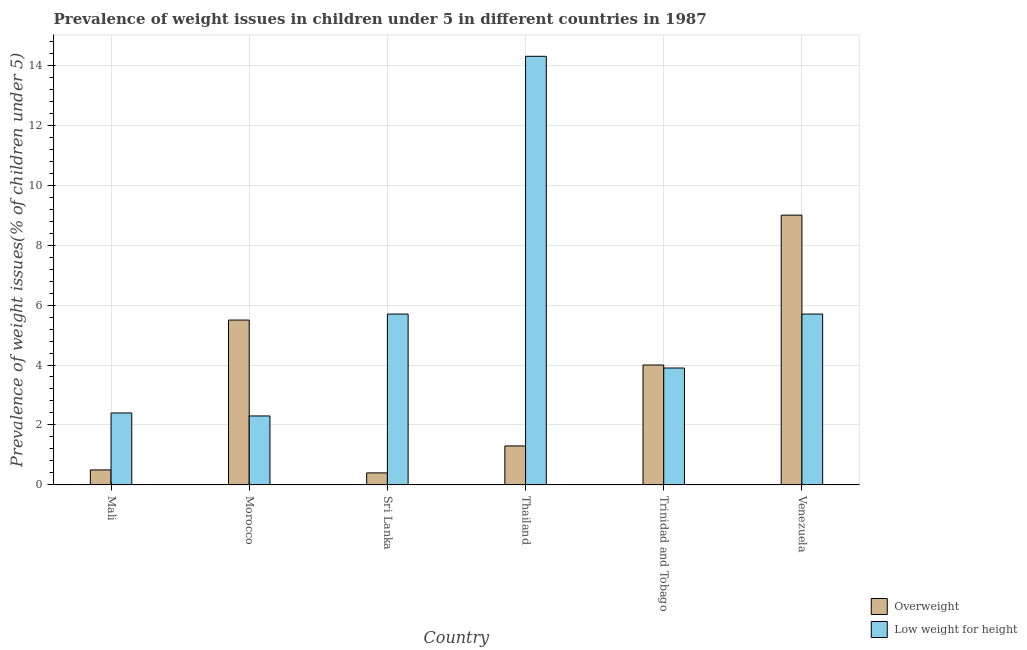How many different coloured bars are there?
Your answer should be very brief. 2. Are the number of bars per tick equal to the number of legend labels?
Offer a terse response. Yes. Are the number of bars on each tick of the X-axis equal?
Make the answer very short. Yes. What is the label of the 4th group of bars from the left?
Make the answer very short. Thailand. What is the percentage of underweight children in Trinidad and Tobago?
Offer a terse response. 3.9. Across all countries, what is the maximum percentage of underweight children?
Your answer should be very brief. 14.3. Across all countries, what is the minimum percentage of underweight children?
Your response must be concise. 2.3. In which country was the percentage of overweight children maximum?
Your response must be concise. Venezuela. In which country was the percentage of underweight children minimum?
Your answer should be very brief. Morocco. What is the total percentage of overweight children in the graph?
Ensure brevity in your answer.  20.7. What is the difference between the percentage of overweight children in Mali and the percentage of underweight children in Venezuela?
Ensure brevity in your answer.  -5.2. What is the average percentage of underweight children per country?
Your answer should be compact. 5.72. What is the difference between the percentage of overweight children and percentage of underweight children in Trinidad and Tobago?
Your answer should be very brief. 0.1. In how many countries, is the percentage of underweight children greater than 12.4 %?
Offer a very short reply. 1. What is the ratio of the percentage of underweight children in Morocco to that in Trinidad and Tobago?
Offer a very short reply. 0.59. Is the difference between the percentage of overweight children in Morocco and Venezuela greater than the difference between the percentage of underweight children in Morocco and Venezuela?
Offer a very short reply. No. What is the difference between the highest and the second highest percentage of underweight children?
Your answer should be very brief. 8.6. What is the difference between the highest and the lowest percentage of overweight children?
Your response must be concise. 8.6. In how many countries, is the percentage of underweight children greater than the average percentage of underweight children taken over all countries?
Give a very brief answer. 1. What does the 1st bar from the left in Sri Lanka represents?
Provide a short and direct response. Overweight. What does the 2nd bar from the right in Trinidad and Tobago represents?
Your answer should be very brief. Overweight. How many bars are there?
Your answer should be compact. 12. Are all the bars in the graph horizontal?
Ensure brevity in your answer.  No. How many countries are there in the graph?
Give a very brief answer. 6. What is the difference between two consecutive major ticks on the Y-axis?
Make the answer very short. 2. Does the graph contain grids?
Your answer should be very brief. Yes. Where does the legend appear in the graph?
Your answer should be compact. Bottom right. What is the title of the graph?
Your response must be concise. Prevalence of weight issues in children under 5 in different countries in 1987. Does "Public funds" appear as one of the legend labels in the graph?
Give a very brief answer. No. What is the label or title of the X-axis?
Provide a short and direct response. Country. What is the label or title of the Y-axis?
Ensure brevity in your answer.  Prevalence of weight issues(% of children under 5). What is the Prevalence of weight issues(% of children under 5) of Low weight for height in Mali?
Provide a succinct answer. 2.4. What is the Prevalence of weight issues(% of children under 5) of Low weight for height in Morocco?
Give a very brief answer. 2.3. What is the Prevalence of weight issues(% of children under 5) of Overweight in Sri Lanka?
Give a very brief answer. 0.4. What is the Prevalence of weight issues(% of children under 5) in Low weight for height in Sri Lanka?
Ensure brevity in your answer.  5.7. What is the Prevalence of weight issues(% of children under 5) of Overweight in Thailand?
Make the answer very short. 1.3. What is the Prevalence of weight issues(% of children under 5) in Low weight for height in Thailand?
Provide a short and direct response. 14.3. What is the Prevalence of weight issues(% of children under 5) of Low weight for height in Trinidad and Tobago?
Your answer should be compact. 3.9. What is the Prevalence of weight issues(% of children under 5) of Overweight in Venezuela?
Your response must be concise. 9. What is the Prevalence of weight issues(% of children under 5) in Low weight for height in Venezuela?
Your answer should be compact. 5.7. Across all countries, what is the maximum Prevalence of weight issues(% of children under 5) of Overweight?
Your answer should be compact. 9. Across all countries, what is the maximum Prevalence of weight issues(% of children under 5) of Low weight for height?
Offer a very short reply. 14.3. Across all countries, what is the minimum Prevalence of weight issues(% of children under 5) of Overweight?
Your response must be concise. 0.4. Across all countries, what is the minimum Prevalence of weight issues(% of children under 5) of Low weight for height?
Provide a short and direct response. 2.3. What is the total Prevalence of weight issues(% of children under 5) in Overweight in the graph?
Keep it short and to the point. 20.7. What is the total Prevalence of weight issues(% of children under 5) of Low weight for height in the graph?
Offer a very short reply. 34.3. What is the difference between the Prevalence of weight issues(% of children under 5) in Overweight in Mali and that in Morocco?
Offer a very short reply. -5. What is the difference between the Prevalence of weight issues(% of children under 5) in Overweight in Mali and that in Sri Lanka?
Offer a terse response. 0.1. What is the difference between the Prevalence of weight issues(% of children under 5) of Overweight in Mali and that in Thailand?
Your response must be concise. -0.8. What is the difference between the Prevalence of weight issues(% of children under 5) in Overweight in Morocco and that in Thailand?
Your answer should be very brief. 4.2. What is the difference between the Prevalence of weight issues(% of children under 5) in Overweight in Morocco and that in Trinidad and Tobago?
Your answer should be compact. 1.5. What is the difference between the Prevalence of weight issues(% of children under 5) in Low weight for height in Morocco and that in Trinidad and Tobago?
Ensure brevity in your answer.  -1.6. What is the difference between the Prevalence of weight issues(% of children under 5) of Overweight in Sri Lanka and that in Thailand?
Offer a terse response. -0.9. What is the difference between the Prevalence of weight issues(% of children under 5) in Low weight for height in Sri Lanka and that in Thailand?
Provide a succinct answer. -8.6. What is the difference between the Prevalence of weight issues(% of children under 5) in Overweight in Sri Lanka and that in Trinidad and Tobago?
Keep it short and to the point. -3.6. What is the difference between the Prevalence of weight issues(% of children under 5) of Low weight for height in Sri Lanka and that in Trinidad and Tobago?
Give a very brief answer. 1.8. What is the difference between the Prevalence of weight issues(% of children under 5) of Overweight in Sri Lanka and that in Venezuela?
Offer a terse response. -8.6. What is the difference between the Prevalence of weight issues(% of children under 5) in Overweight in Thailand and that in Trinidad and Tobago?
Give a very brief answer. -2.7. What is the difference between the Prevalence of weight issues(% of children under 5) in Low weight for height in Thailand and that in Trinidad and Tobago?
Offer a very short reply. 10.4. What is the difference between the Prevalence of weight issues(% of children under 5) of Overweight in Thailand and that in Venezuela?
Offer a terse response. -7.7. What is the difference between the Prevalence of weight issues(% of children under 5) in Low weight for height in Trinidad and Tobago and that in Venezuela?
Your response must be concise. -1.8. What is the difference between the Prevalence of weight issues(% of children under 5) of Overweight in Mali and the Prevalence of weight issues(% of children under 5) of Low weight for height in Morocco?
Your response must be concise. -1.8. What is the difference between the Prevalence of weight issues(% of children under 5) in Overweight in Mali and the Prevalence of weight issues(% of children under 5) in Low weight for height in Sri Lanka?
Provide a short and direct response. -5.2. What is the difference between the Prevalence of weight issues(% of children under 5) in Overweight in Morocco and the Prevalence of weight issues(% of children under 5) in Low weight for height in Sri Lanka?
Provide a short and direct response. -0.2. What is the difference between the Prevalence of weight issues(% of children under 5) in Overweight in Sri Lanka and the Prevalence of weight issues(% of children under 5) in Low weight for height in Thailand?
Make the answer very short. -13.9. What is the difference between the Prevalence of weight issues(% of children under 5) of Overweight in Sri Lanka and the Prevalence of weight issues(% of children under 5) of Low weight for height in Venezuela?
Your answer should be very brief. -5.3. What is the difference between the Prevalence of weight issues(% of children under 5) of Overweight in Thailand and the Prevalence of weight issues(% of children under 5) of Low weight for height in Venezuela?
Ensure brevity in your answer.  -4.4. What is the average Prevalence of weight issues(% of children under 5) in Overweight per country?
Provide a short and direct response. 3.45. What is the average Prevalence of weight issues(% of children under 5) of Low weight for height per country?
Provide a succinct answer. 5.72. What is the difference between the Prevalence of weight issues(% of children under 5) of Overweight and Prevalence of weight issues(% of children under 5) of Low weight for height in Mali?
Make the answer very short. -1.9. What is the difference between the Prevalence of weight issues(% of children under 5) of Overweight and Prevalence of weight issues(% of children under 5) of Low weight for height in Morocco?
Offer a very short reply. 3.2. What is the difference between the Prevalence of weight issues(% of children under 5) in Overweight and Prevalence of weight issues(% of children under 5) in Low weight for height in Thailand?
Your response must be concise. -13. What is the difference between the Prevalence of weight issues(% of children under 5) in Overweight and Prevalence of weight issues(% of children under 5) in Low weight for height in Trinidad and Tobago?
Offer a very short reply. 0.1. What is the difference between the Prevalence of weight issues(% of children under 5) of Overweight and Prevalence of weight issues(% of children under 5) of Low weight for height in Venezuela?
Ensure brevity in your answer.  3.3. What is the ratio of the Prevalence of weight issues(% of children under 5) in Overweight in Mali to that in Morocco?
Give a very brief answer. 0.09. What is the ratio of the Prevalence of weight issues(% of children under 5) in Low weight for height in Mali to that in Morocco?
Keep it short and to the point. 1.04. What is the ratio of the Prevalence of weight issues(% of children under 5) in Overweight in Mali to that in Sri Lanka?
Keep it short and to the point. 1.25. What is the ratio of the Prevalence of weight issues(% of children under 5) of Low weight for height in Mali to that in Sri Lanka?
Keep it short and to the point. 0.42. What is the ratio of the Prevalence of weight issues(% of children under 5) of Overweight in Mali to that in Thailand?
Provide a succinct answer. 0.38. What is the ratio of the Prevalence of weight issues(% of children under 5) of Low weight for height in Mali to that in Thailand?
Your response must be concise. 0.17. What is the ratio of the Prevalence of weight issues(% of children under 5) of Low weight for height in Mali to that in Trinidad and Tobago?
Offer a very short reply. 0.62. What is the ratio of the Prevalence of weight issues(% of children under 5) of Overweight in Mali to that in Venezuela?
Provide a succinct answer. 0.06. What is the ratio of the Prevalence of weight issues(% of children under 5) in Low weight for height in Mali to that in Venezuela?
Your answer should be very brief. 0.42. What is the ratio of the Prevalence of weight issues(% of children under 5) of Overweight in Morocco to that in Sri Lanka?
Your response must be concise. 13.75. What is the ratio of the Prevalence of weight issues(% of children under 5) in Low weight for height in Morocco to that in Sri Lanka?
Provide a succinct answer. 0.4. What is the ratio of the Prevalence of weight issues(% of children under 5) in Overweight in Morocco to that in Thailand?
Offer a very short reply. 4.23. What is the ratio of the Prevalence of weight issues(% of children under 5) of Low weight for height in Morocco to that in Thailand?
Your answer should be compact. 0.16. What is the ratio of the Prevalence of weight issues(% of children under 5) of Overweight in Morocco to that in Trinidad and Tobago?
Your response must be concise. 1.38. What is the ratio of the Prevalence of weight issues(% of children under 5) in Low weight for height in Morocco to that in Trinidad and Tobago?
Keep it short and to the point. 0.59. What is the ratio of the Prevalence of weight issues(% of children under 5) of Overweight in Morocco to that in Venezuela?
Give a very brief answer. 0.61. What is the ratio of the Prevalence of weight issues(% of children under 5) of Low weight for height in Morocco to that in Venezuela?
Give a very brief answer. 0.4. What is the ratio of the Prevalence of weight issues(% of children under 5) of Overweight in Sri Lanka to that in Thailand?
Provide a succinct answer. 0.31. What is the ratio of the Prevalence of weight issues(% of children under 5) in Low weight for height in Sri Lanka to that in Thailand?
Offer a very short reply. 0.4. What is the ratio of the Prevalence of weight issues(% of children under 5) of Low weight for height in Sri Lanka to that in Trinidad and Tobago?
Offer a very short reply. 1.46. What is the ratio of the Prevalence of weight issues(% of children under 5) of Overweight in Sri Lanka to that in Venezuela?
Provide a succinct answer. 0.04. What is the ratio of the Prevalence of weight issues(% of children under 5) in Low weight for height in Sri Lanka to that in Venezuela?
Give a very brief answer. 1. What is the ratio of the Prevalence of weight issues(% of children under 5) of Overweight in Thailand to that in Trinidad and Tobago?
Keep it short and to the point. 0.33. What is the ratio of the Prevalence of weight issues(% of children under 5) of Low weight for height in Thailand to that in Trinidad and Tobago?
Offer a terse response. 3.67. What is the ratio of the Prevalence of weight issues(% of children under 5) in Overweight in Thailand to that in Venezuela?
Your answer should be very brief. 0.14. What is the ratio of the Prevalence of weight issues(% of children under 5) in Low weight for height in Thailand to that in Venezuela?
Your answer should be compact. 2.51. What is the ratio of the Prevalence of weight issues(% of children under 5) in Overweight in Trinidad and Tobago to that in Venezuela?
Offer a very short reply. 0.44. What is the ratio of the Prevalence of weight issues(% of children under 5) in Low weight for height in Trinidad and Tobago to that in Venezuela?
Offer a very short reply. 0.68. 